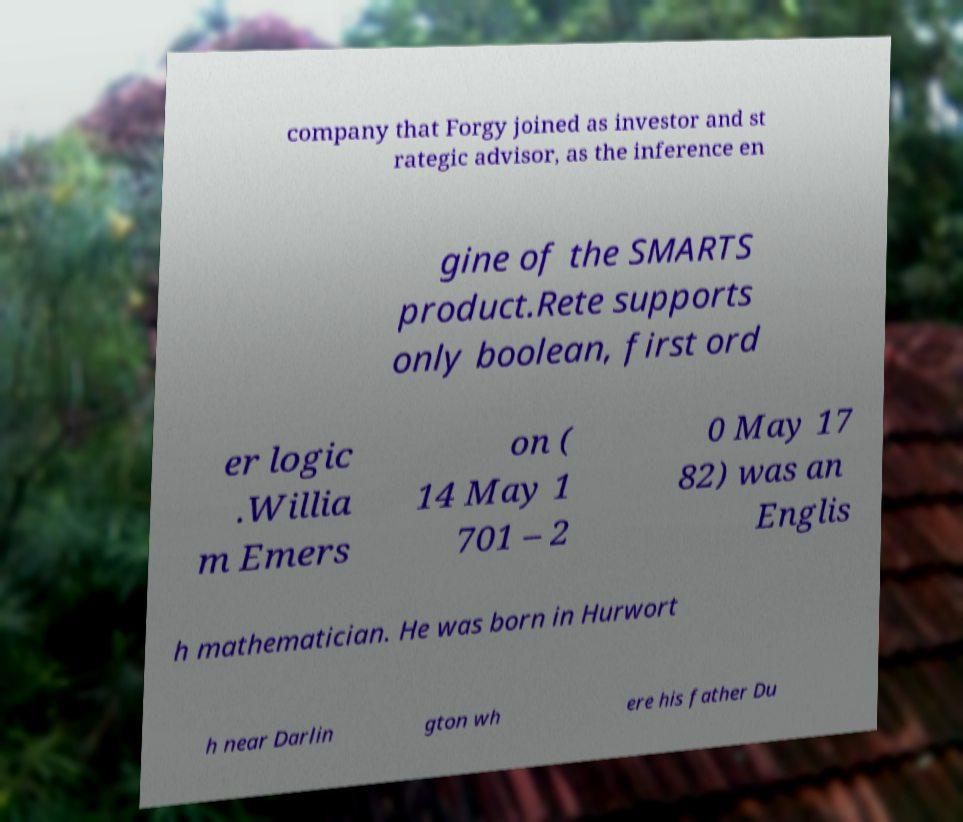Please read and relay the text visible in this image. What does it say? company that Forgy joined as investor and st rategic advisor, as the inference en gine of the SMARTS product.Rete supports only boolean, first ord er logic .Willia m Emers on ( 14 May 1 701 – 2 0 May 17 82) was an Englis h mathematician. He was born in Hurwort h near Darlin gton wh ere his father Du 